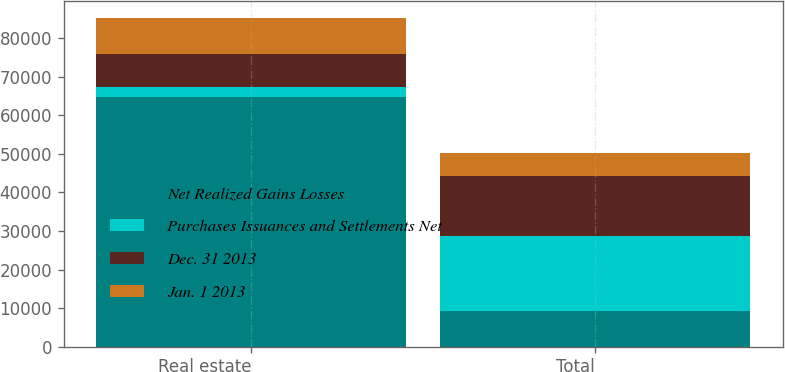Convert chart to OTSL. <chart><loc_0><loc_0><loc_500><loc_500><stacked_bar_chart><ecel><fcel>Real estate<fcel>Total<nl><fcel>Net Realized Gains Losses<fcel>64597<fcel>9317<nl><fcel>Purchases Issuances and Settlements Net<fcel>2659<fcel>19399<nl><fcel>Dec. 31 2013<fcel>8690<fcel>15645<nl><fcel>Jan. 1 2013<fcel>9317<fcel>5945<nl></chart> 